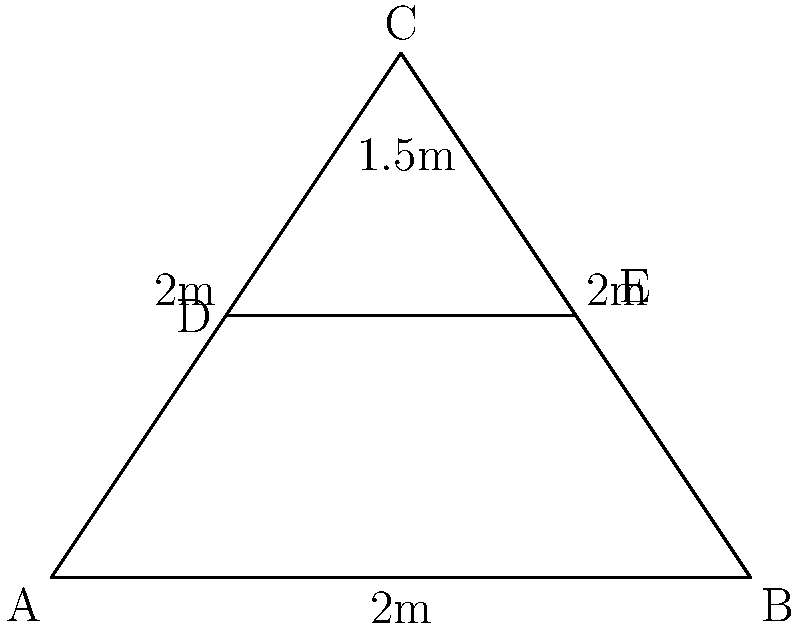In your boxing ring, you've marked out a triangular training zone ABC with a line DE parallel to the base AB. If AB = 4m, DE = 2m, and the perpendicular distance from C to AB is 3m, prove that triangle ADE is congruent to triangle BEC. Let's approach this step-by-step:

1) First, we need to show that triangles ADE and BEC share the same properties that make them congruent.

2) We can use the AAS (Angle-Angle-Side) congruence theorem. This states that if two angles and the included side of one triangle are equal to the corresponding parts of another triangle, the triangles are congruent.

3) Let's start with the angles:
   - Angle AED = Angle BEC (vertically opposite angles)
   - Angle DAE = Angle CBE (alternate angles, as DE || AB)

4) Now, we need to prove that AD = BE:
   - DE is parallel to AB and bisects AC and BC (given in the diagram)
   - This means that D is the midpoint of AC and E is the midpoint of BC
   - Therefore, AD = DC and BE = EC
   - As the perpendicular height of the triangle is 3m, and AB = 4m, we can use the properties of similar triangles:
     $$\frac{AD}{AB} = \frac{DE}{AB} = \frac{2}{4} = \frac{1}{2}$$
   - So, AD = BE = 2m

5) We have now shown that:
   - Two pairs of corresponding angles are equal
   - The included side (AD and BE) are equal

6) By the AAS congruence theorem, triangle ADE is congruent to triangle BEC.
Answer: Triangles ADE and BEC are congruent by AAS. 